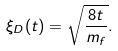Convert formula to latex. <formula><loc_0><loc_0><loc_500><loc_500>\xi _ { D } ( t ) = \sqrt { \frac { 8 t } { m _ { f } } } .</formula> 